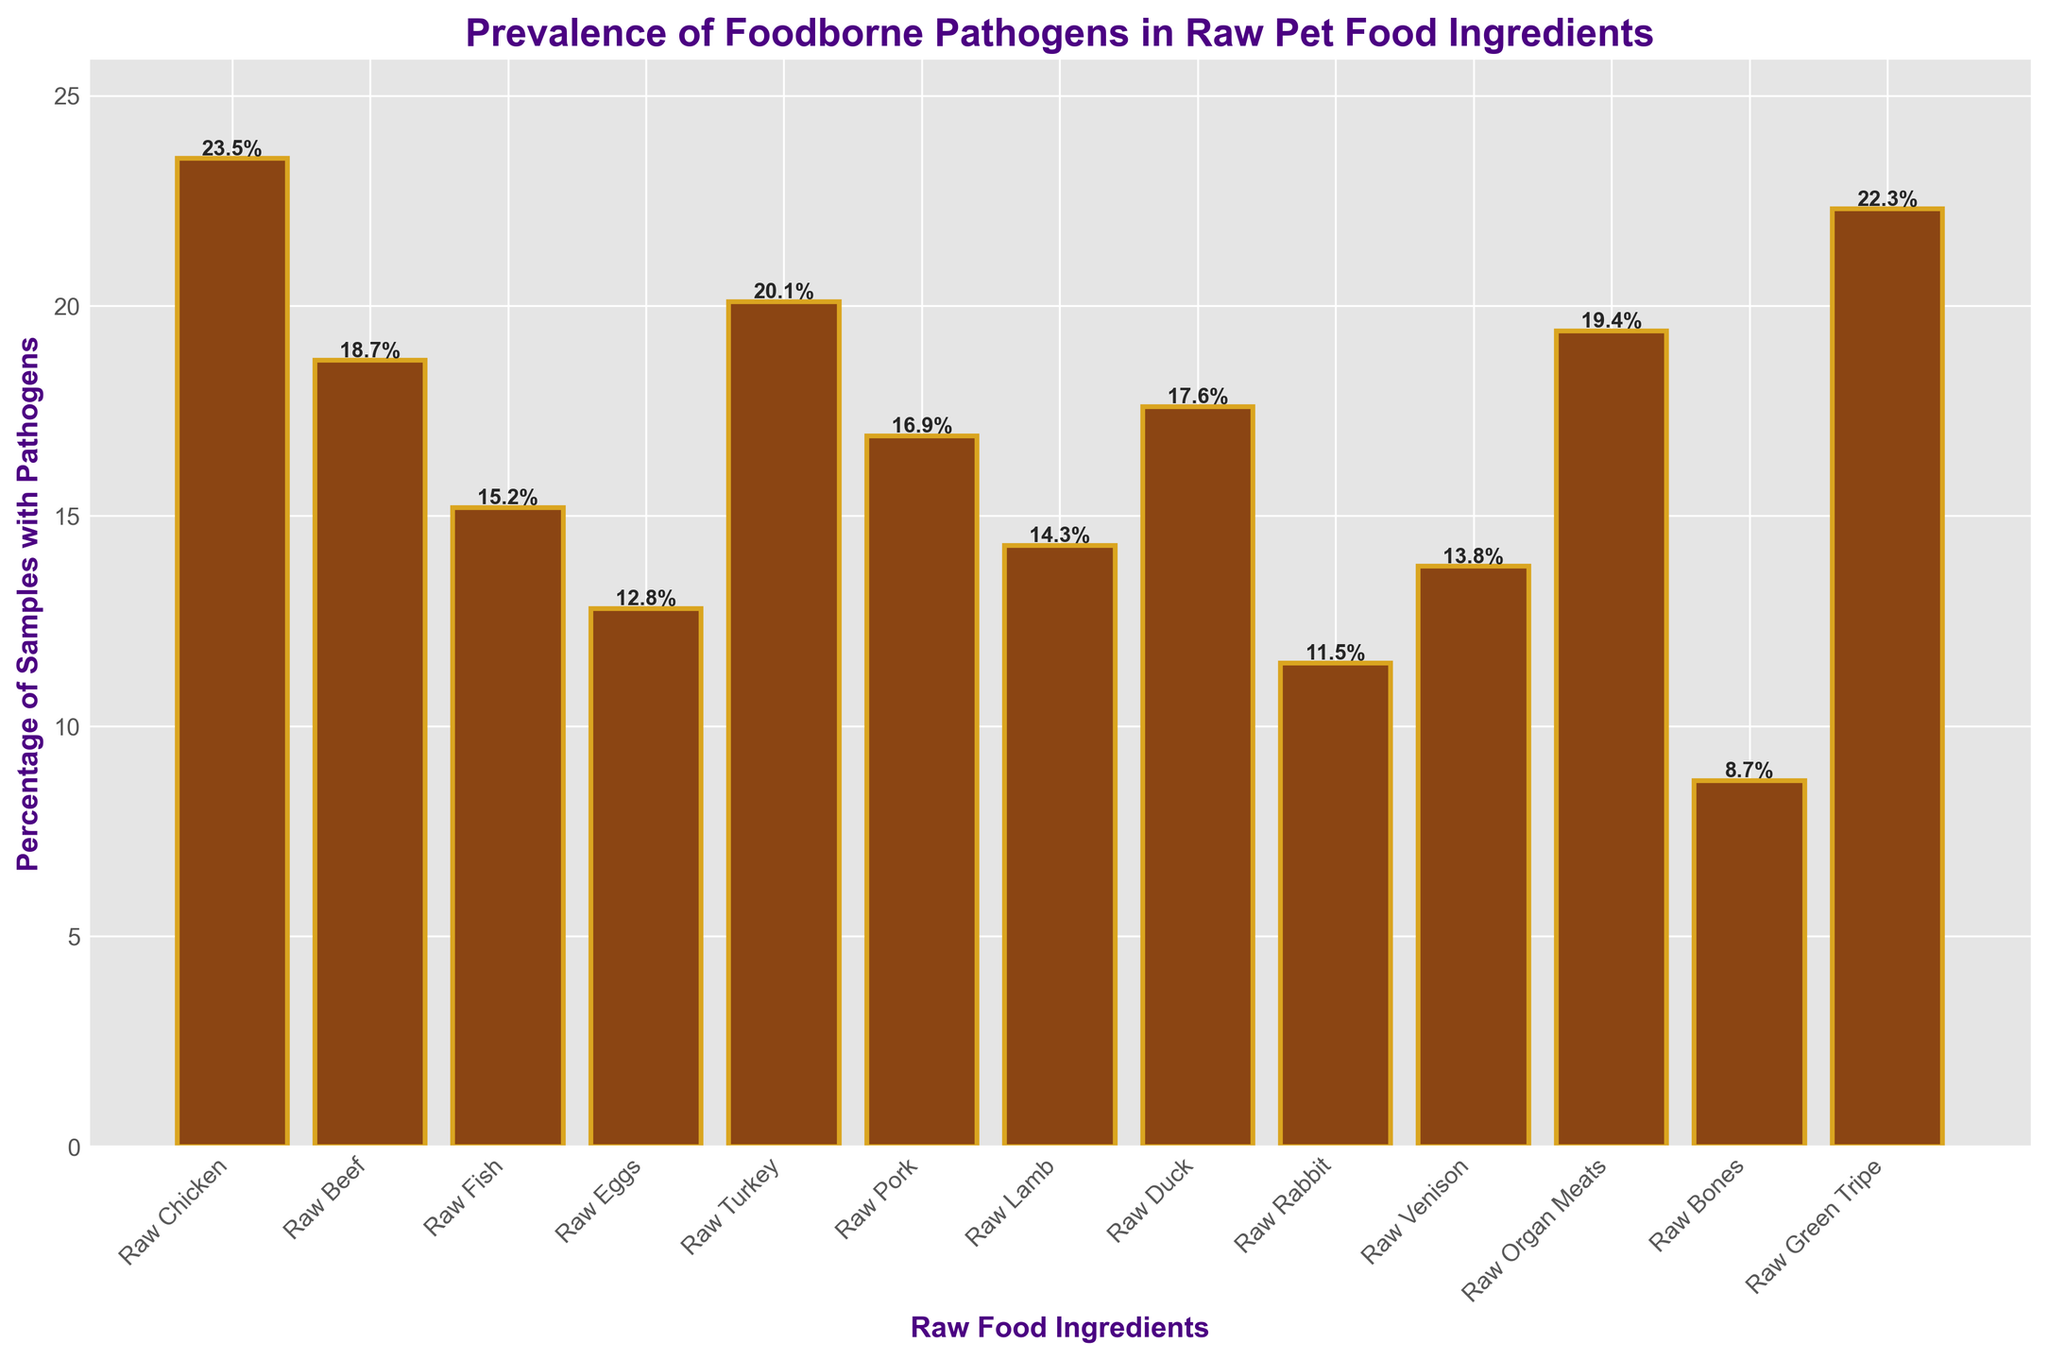Which raw food ingredient has the highest prevalence of foodborne pathogens? Look for the tallest bar in the bar chart, which represents the highest percentage of samples containing pathogens. The bar for "Raw Chicken" is the tallest with 23.5%.
Answer: Raw Chicken Which ingredient has the lowest percentage of samples containing pathogens? Identify the shortest bar in the bar chart, which corresponds to the lowest prevalence. The bar for "Raw Bones" is the shortest with 8.7%.
Answer: Raw Bones What is the average percentage of samples containing pathogens across all ingredients? Sum all the percentages and divide by the number of ingredients (13). Calculate the sum: 23.5 + 18.7 + 15.2 + 12.8 + 20.1 + 16.9 + 14.3 + 17.6 + 11.5 + 13.8 + 19.4 + 8.7 + 22.3 = 215.8. Then, 215.8 / 13 = 16.6.
Answer: 16.6 How does the prevalence of pathogens in Raw Chicken compare to Raw Turkey? Compare the heights of the bars for "Raw Chicken" and "Raw Turkey". "Raw Chicken" has 23.5% while "Raw Turkey" has 20.1%.
Answer: Raw Chicken has a higher prevalence Are there any ingredients with similar prevalence, and if so, which ones? Look for bars that have similar heights. "Raw Green Tripe" (22.3%) and "Raw Chicken" (23.5%), as well as "Raw Pork" (16.9%) and "Raw Duck" (17.6%), have close percentages.
Answer: Raw Chicken and Raw Green Tripe; Raw Pork and Raw Duck What is the combined percentage of samples containing pathogens for Raw Beef, Raw Fish, and Raw Eggs? Sum the percentages for "Raw Beef" (18.7%), "Raw Fish" (15.2%), and "Raw Eggs" (12.8%). 18.7 + 15.2 + 12.8 = 46.7.
Answer: 46.7 Which three ingredients have the highest prevalence of foodborne pathogens? Identify the three tallest bars in the chart, which are "Raw Chicken" (23.5%), "Raw Green Tripe" (22.3%), and "Raw Turkey" (20.1%).
Answer: Raw Chicken, Raw Green Tripe, Raw Turkey How much greater is the percentage of samples containing pathogens in Raw Organ Meats compared to Raw Lamb? Subtract the percentage for "Raw Lamb" from "Raw Organ Meats", 19.4% - 14.3% = 5.1%.
Answer: 5.1 Which ingredient has a lower prevalence of pathogens, Raw Rabbit or Raw Venison? Compare the heights of the bars for "Raw Rabbit" (11.5%) and "Raw Venison" (13.8%).
Answer: Raw Rabbit 